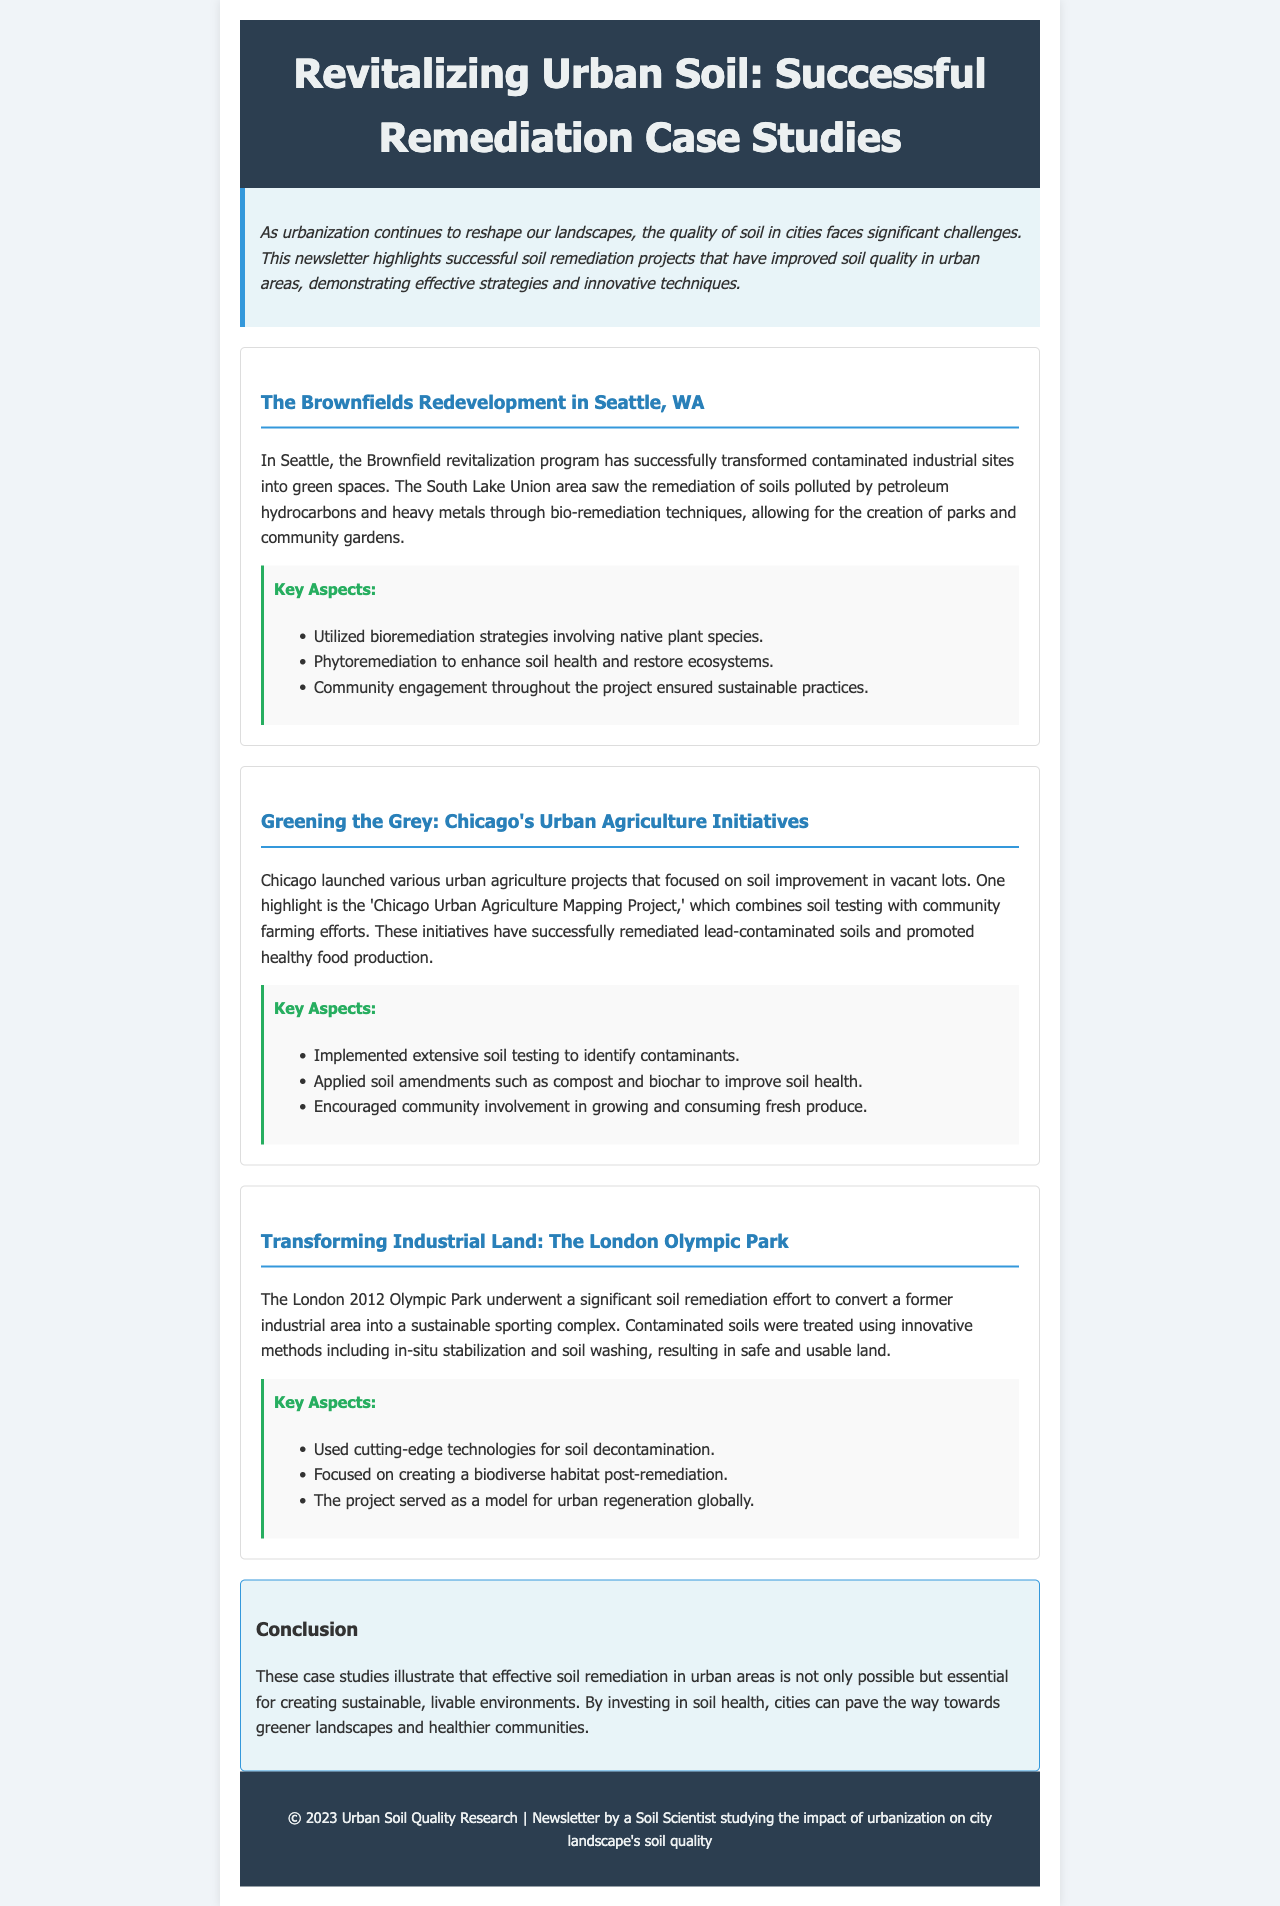what is the title of the newsletter? The title of the newsletter is provided in the header section.
Answer: Revitalizing Urban Soil: Successful Remediation Case Studies which city is highlighted for the Brownfields Redevelopment project? The project location is explicitly mentioned in the case study section.
Answer: Seattle, WA what method was used for soil remediation in the Chicago urban agriculture initiatives? The methods employed in the Chicago initiatives are listed in the key aspects section.
Answer: soil amendments such as compost and biochar how many case studies are presented in the document? The document lists three distinct case studies within the case studies section.
Answer: three which key aspect involved community engagement in the Seattle project? The key aspects of the case studies mention specific strategies related to community involvement.
Answer: Community engagement throughout the project what goal was achieved by the London Olympic Park remediation project? The results of the project are summarized in the conclusion section regarding land usability.
Answer: safe and usable land which type of technique was primarily used in the Seattle project? The specific techniques used in the Seattle project are highlighted in the key aspects section.
Answer: bioremediation strategies where can one find the newsletter's copyright information? The copyright details are provided in the footer section of the document.
Answer: footer 